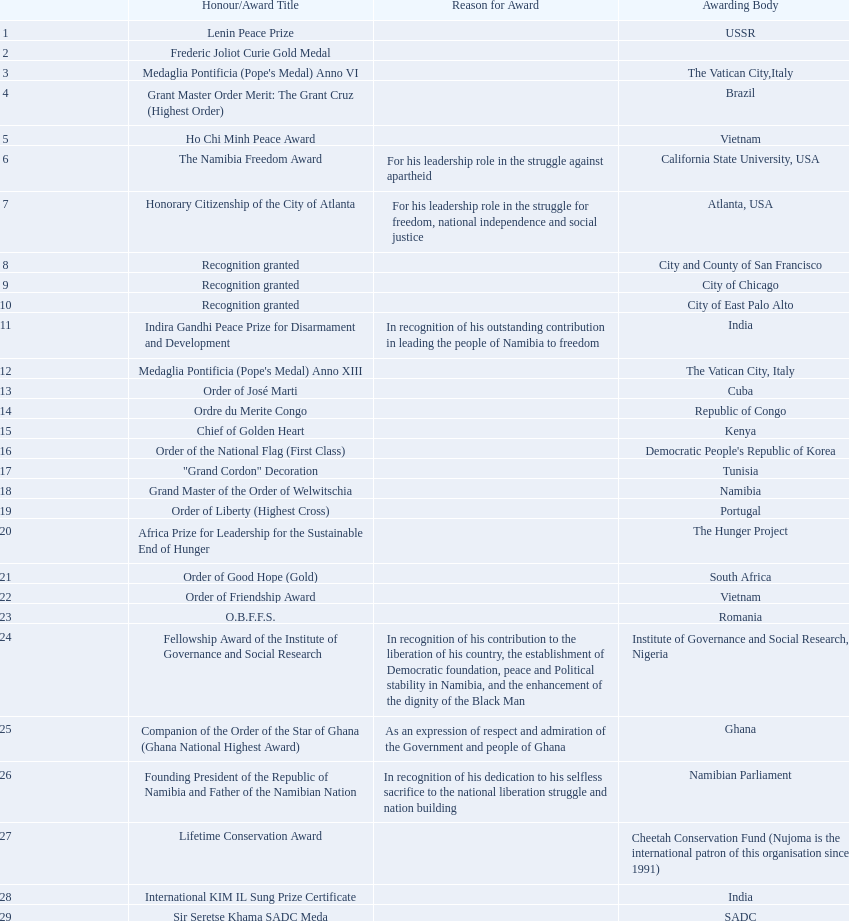What awards has sam nujoma been awarded? Lenin Peace Prize, Frederic Joliot Curie Gold Medal, Medaglia Pontificia (Pope's Medal) Anno VI, Grant Master Order Merit: The Grant Cruz (Highest Order), Ho Chi Minh Peace Award, The Namibia Freedom Award, Honorary Citizenship of the City of Atlanta, Recognition granted, Recognition granted, Recognition granted, Indira Gandhi Peace Prize for Disarmament and Development, Medaglia Pontificia (Pope's Medal) Anno XIII, Order of José Marti, Ordre du Merite Congo, Chief of Golden Heart, Order of the National Flag (First Class), "Grand Cordon" Decoration, Grand Master of the Order of Welwitschia, Order of Liberty (Highest Cross), Africa Prize for Leadership for the Sustainable End of Hunger, Order of Good Hope (Gold), Order of Friendship Award, O.B.F.F.S., Fellowship Award of the Institute of Governance and Social Research, Companion of the Order of the Star of Ghana (Ghana National Highest Award), Founding President of the Republic of Namibia and Father of the Namibian Nation, Lifetime Conservation Award, International KIM IL Sung Prize Certificate, Sir Seretse Khama SADC Meda. By which awarding body did sam nujoma receive the o.b.f.f.s award? Romania. 